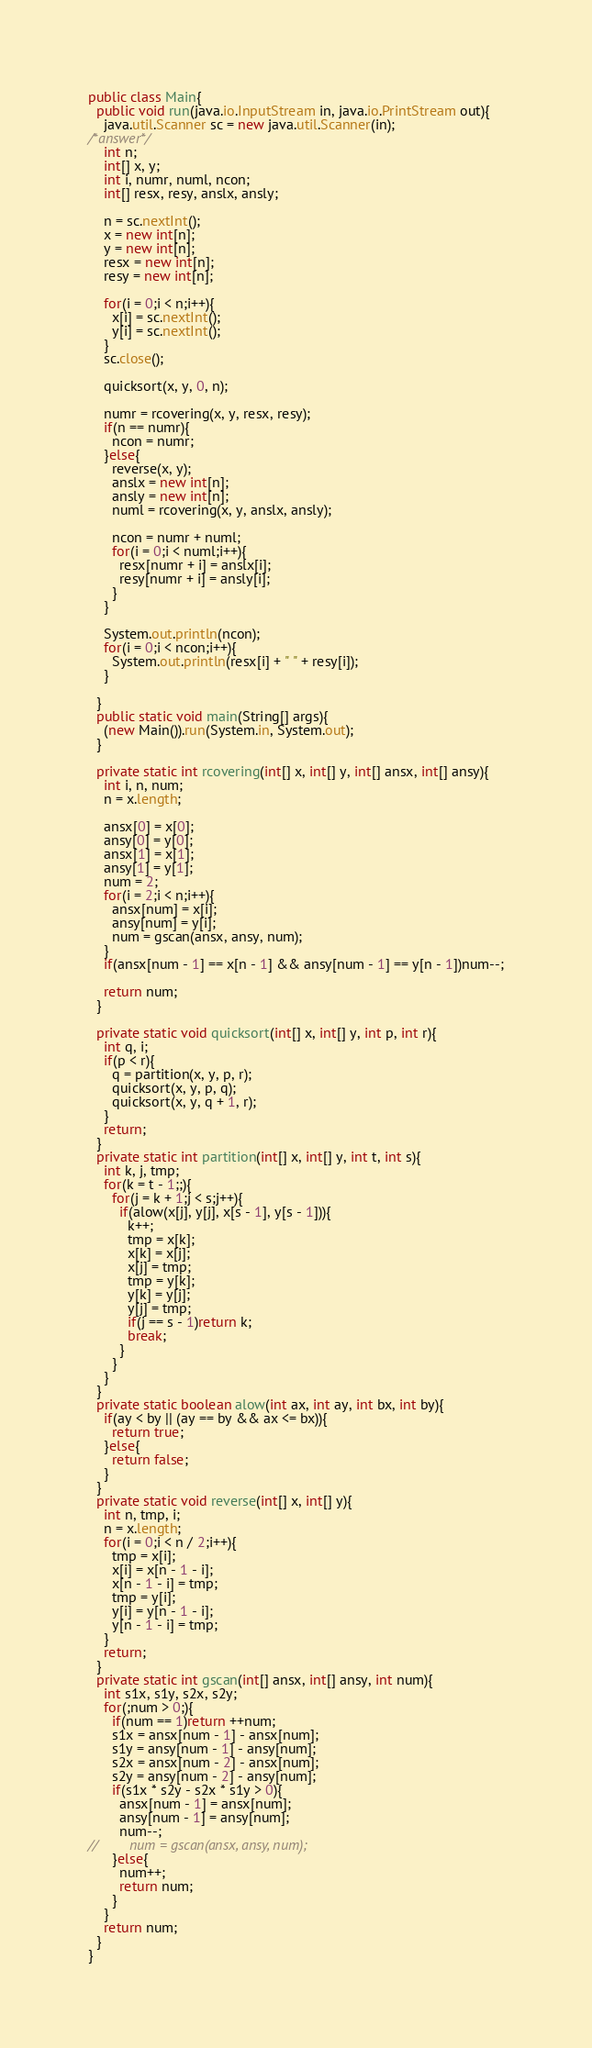Convert code to text. <code><loc_0><loc_0><loc_500><loc_500><_Java_>public class Main{
  public void run(java.io.InputStream in, java.io.PrintStream out){
    java.util.Scanner sc = new java.util.Scanner(in);
/*answer*/
    int n;
    int[] x, y;
    int i, numr, numl, ncon;
    int[] resx, resy, anslx, ansly;

    n = sc.nextInt();
    x = new int[n];
    y = new int[n];
    resx = new int[n];
    resy = new int[n];

    for(i = 0;i < n;i++){
      x[i] = sc.nextInt();
      y[i] = sc.nextInt();
    }
    sc.close();

    quicksort(x, y, 0, n);

    numr = rcovering(x, y, resx, resy);
    if(n == numr){
      ncon = numr;
    }else{
      reverse(x, y);
      anslx = new int[n];
      ansly = new int[n];
      numl = rcovering(x, y, anslx, ansly);

      ncon = numr + numl;
      for(i = 0;i < numl;i++){
        resx[numr + i] = anslx[i];
        resy[numr + i] = ansly[i];
      }
    }
    
    System.out.println(ncon);
    for(i = 0;i < ncon;i++){
      System.out.println(resx[i] + " " + resy[i]);
    }

  }
  public static void main(String[] args){
    (new Main()).run(System.in, System.out);
  }

  private static int rcovering(int[] x, int[] y, int[] ansx, int[] ansy){
    int i, n, num;
    n = x.length;

    ansx[0] = x[0];
    ansy[0] = y[0];
    ansx[1] = x[1];
    ansy[1] = y[1];
    num = 2;
    for(i = 2;i < n;i++){
      ansx[num] = x[i];
      ansy[num] = y[i];
      num = gscan(ansx, ansy, num);
    }
    if(ansx[num - 1] == x[n - 1] && ansy[num - 1] == y[n - 1])num--;

    return num;
  }

  private static void quicksort(int[] x, int[] y, int p, int r){
    int q, i;
    if(p < r){
      q = partition(x, y, p, r);
      quicksort(x, y, p, q);
      quicksort(x, y, q + 1, r);
    }
    return;
  }
  private static int partition(int[] x, int[] y, int t, int s){
    int k, j, tmp;
    for(k = t - 1;;){
      for(j = k + 1;j < s;j++){
        if(alow(x[j], y[j], x[s - 1], y[s - 1])){
          k++;
          tmp = x[k];
          x[k] = x[j];
          x[j] = tmp;
          tmp = y[k];
          y[k] = y[j];
          y[j] = tmp;
          if(j == s - 1)return k;
          break;
        }
      }
    }
  }
  private static boolean alow(int ax, int ay, int bx, int by){
    if(ay < by || (ay == by && ax <= bx)){
      return true;
    }else{
      return false;
    }
  }
  private static void reverse(int[] x, int[] y){
    int n, tmp, i;
    n = x.length;
    for(i = 0;i < n / 2;i++){
      tmp = x[i];
      x[i] = x[n - 1 - i];
      x[n - 1 - i] = tmp;
      tmp = y[i];
      y[i] = y[n - 1 - i];
      y[n - 1 - i] = tmp;
    }
    return;
  }
  private static int gscan(int[] ansx, int[] ansy, int num){
    int s1x, s1y, s2x, s2y;
    for(;num > 0;){
      if(num == 1)return ++num;
      s1x = ansx[num - 1] - ansx[num];
      s1y = ansy[num - 1] - ansy[num];
      s2x = ansx[num - 2] - ansx[num];
      s2y = ansy[num - 2] - ansy[num];
      if(s1x * s2y - s2x * s1y > 0){
        ansx[num - 1] = ansx[num];
        ansy[num - 1] = ansy[num];
        num--;
//        num = gscan(ansx, ansy, num);
      }else{
        num++;
        return num;
      }
    }
    return num;
  }
}</code> 